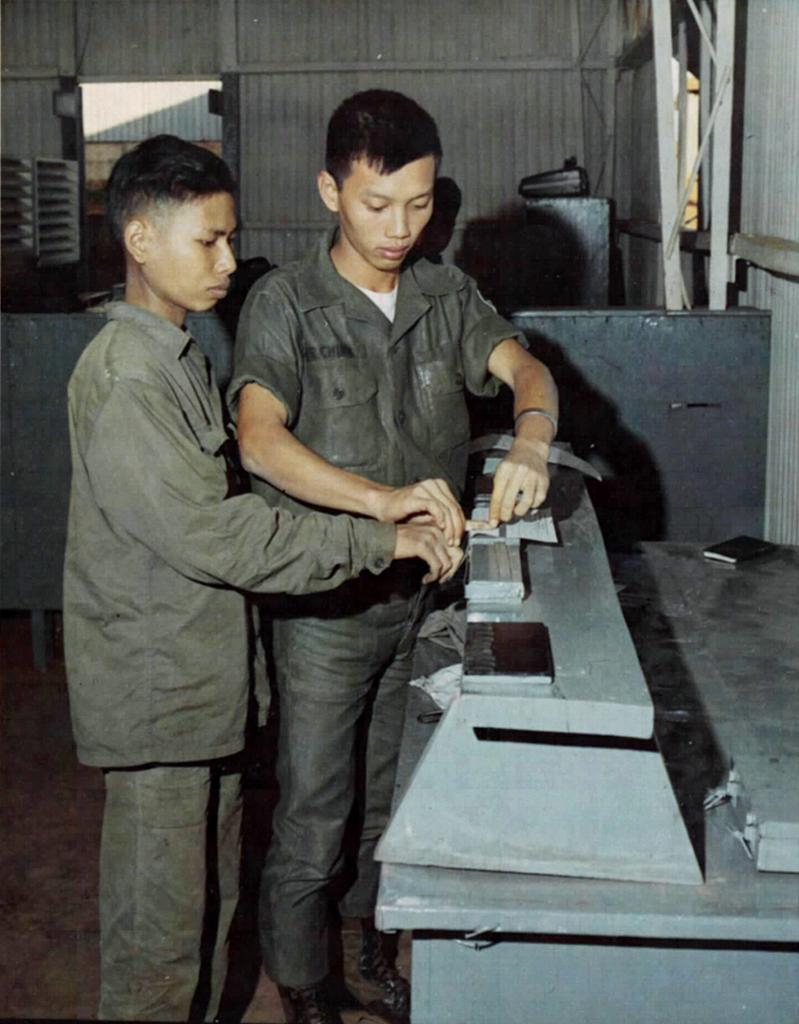How many people are in the image? There are two persons in the image. What are the two persons doing in the image? The two persons are standing and doing some work. Where is the work taking place? The work is taking place inside a shed. What type of rail system is visible in the image? There is no rail system present in the image; it features two persons standing and working inside a shed. 